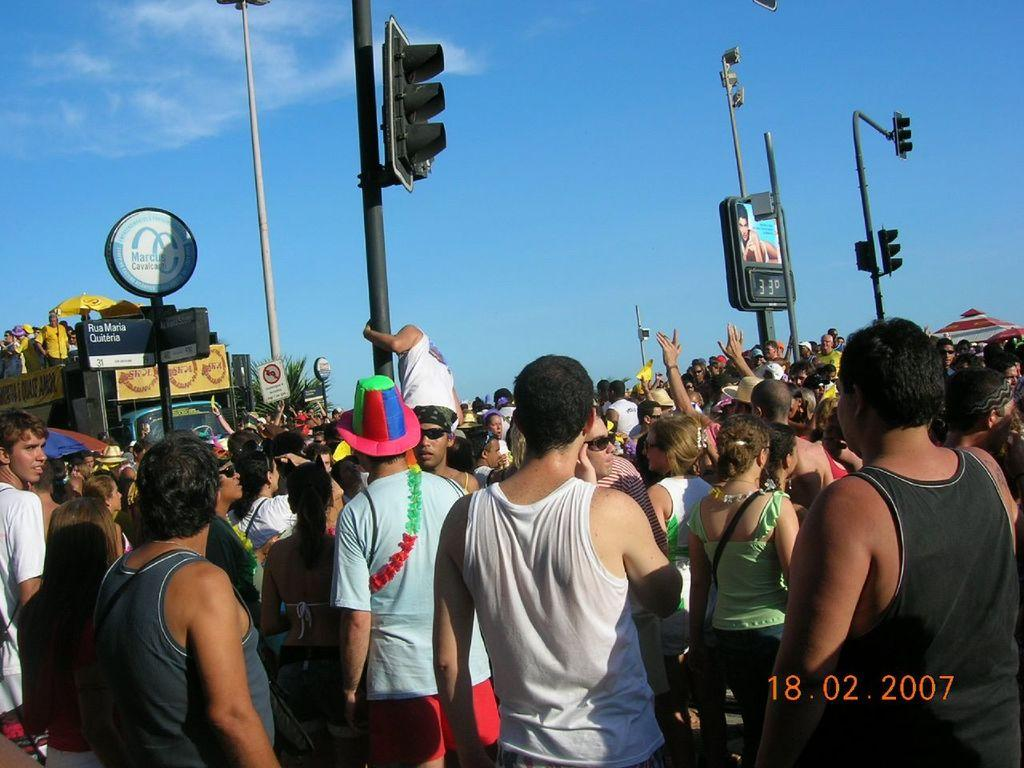What can be seen in the image? There are people standing in the image. What else is present in the image besides people? There are poles in the image. What can be seen in the background of the image? The sky is visible in the background of the image. Is there any text in the image? Yes, there is text at the bottom of the image. What type of clouds can be seen in the image? There are no clouds visible in the image; only the sky is mentioned in the background. 